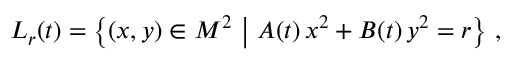<formula> <loc_0><loc_0><loc_500><loc_500>L _ { r } ( t ) = \Big \{ ( x , y ) \in M ^ { 2 } \ \Big | \ A ( t ) \, x ^ { 2 } + B ( t ) \, y ^ { 2 } = r \Big \} \ ,</formula> 